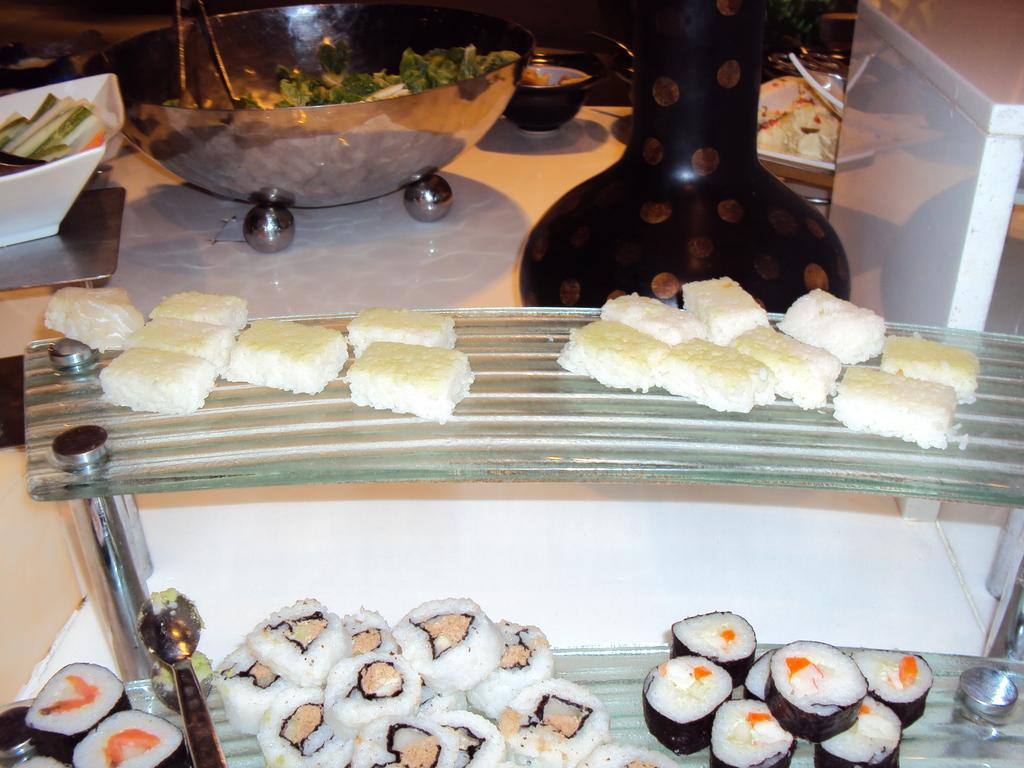What can be found in the racks in the image? There are food places in the racks. What piece of furniture is present in the image? There is a table in the image. What items are on the table? There are food bowls and a vase on the table. How many pages are in the cookbook on the table? There is no cookbook present on the table in the image. What type of loss is depicted in the image? There is no depiction of loss in the image; it features food places, a table, food bowls, and a vase}. 